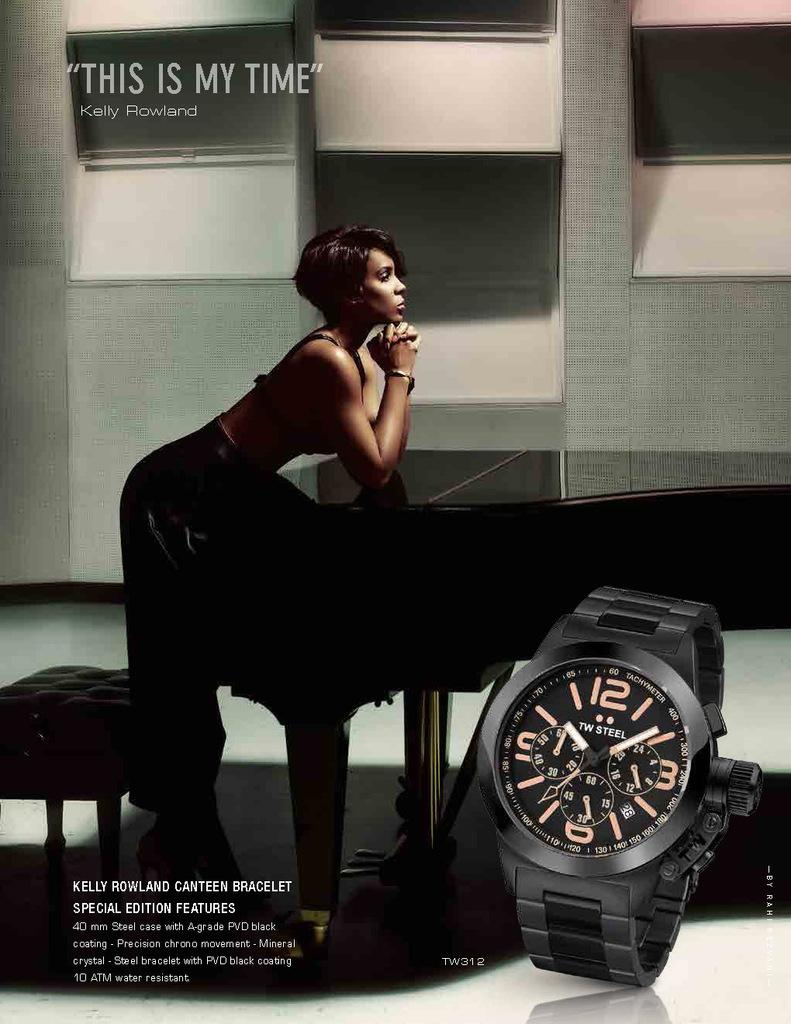<image>
Write a terse but informative summary of the picture. A woman at a piano says 'This is my time" in a watch ad. 